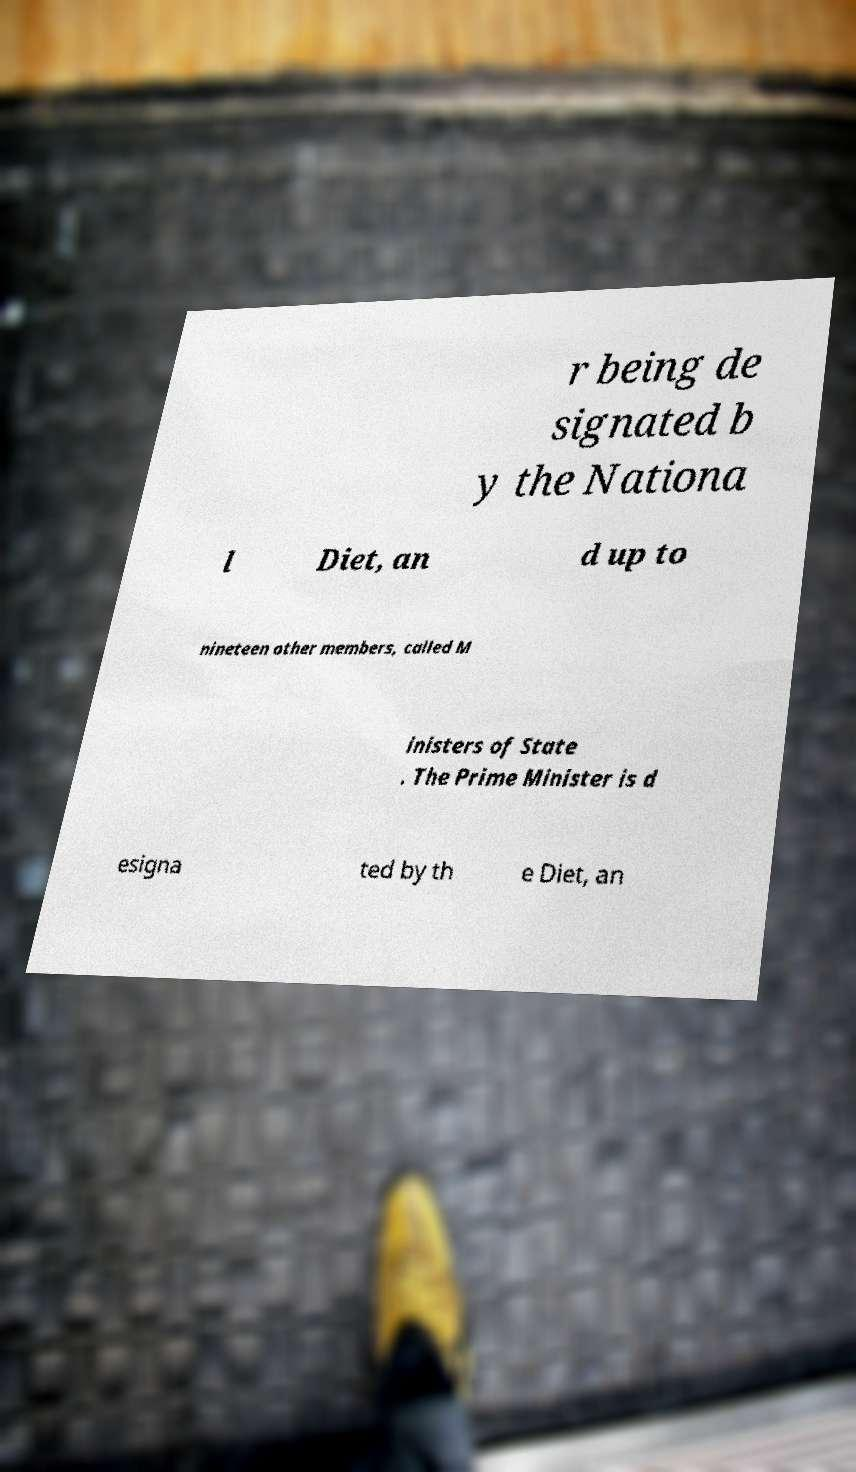Could you assist in decoding the text presented in this image and type it out clearly? r being de signated b y the Nationa l Diet, an d up to nineteen other members, called M inisters of State . The Prime Minister is d esigna ted by th e Diet, an 